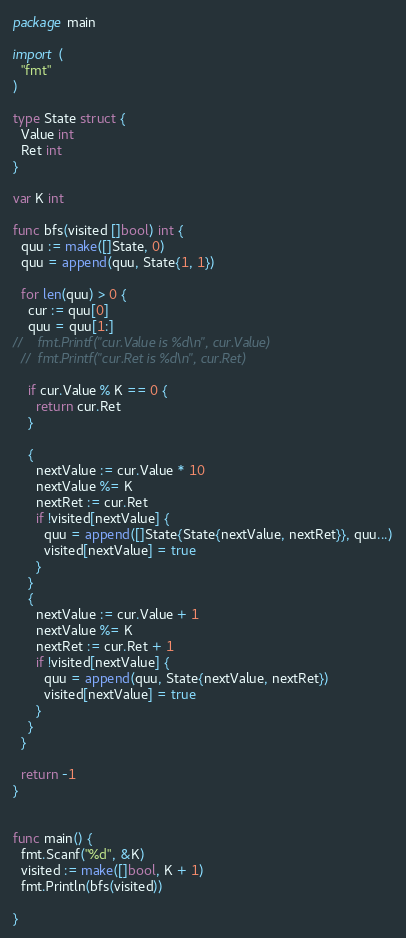Convert code to text. <code><loc_0><loc_0><loc_500><loc_500><_Go_>package main

import (
  "fmt"
)

type State struct {
  Value int
  Ret int
}

var K int

func bfs(visited []bool) int {
  quu := make([]State, 0)
  quu = append(quu, State{1, 1})

  for len(quu) > 0 {
    cur := quu[0]
    quu = quu[1:]
//    fmt.Printf("cur.Value is %d\n", cur.Value)
  //  fmt.Printf("cur.Ret is %d\n", cur.Ret)

    if cur.Value % K == 0 {
      return cur.Ret
    }

    {
      nextValue := cur.Value * 10
      nextValue %= K
      nextRet := cur.Ret
      if !visited[nextValue] {
        quu = append([]State{State{nextValue, nextRet}}, quu...)
        visited[nextValue] = true
      }
    }
    {
      nextValue := cur.Value + 1
      nextValue %= K
      nextRet := cur.Ret + 1
      if !visited[nextValue] {
        quu = append(quu, State{nextValue, nextRet})
        visited[nextValue] = true
      }
    }
  }

  return -1
}


func main() {
  fmt.Scanf("%d", &K)
  visited := make([]bool, K + 1)
  fmt.Println(bfs(visited))

}
</code> 